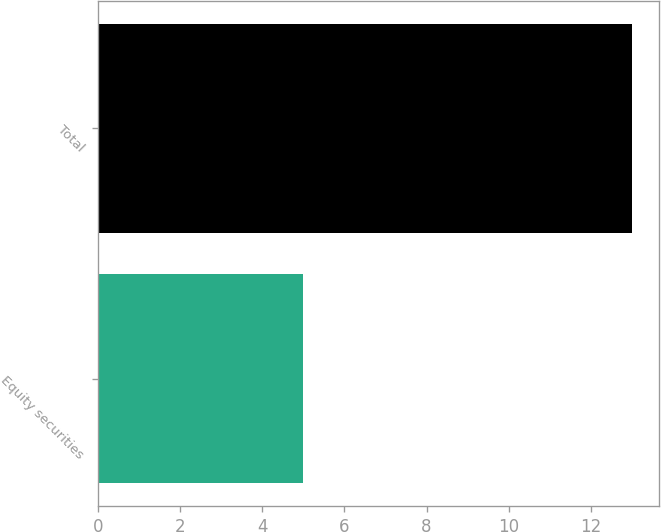Convert chart. <chart><loc_0><loc_0><loc_500><loc_500><bar_chart><fcel>Equity securities<fcel>Total<nl><fcel>5<fcel>13<nl></chart> 